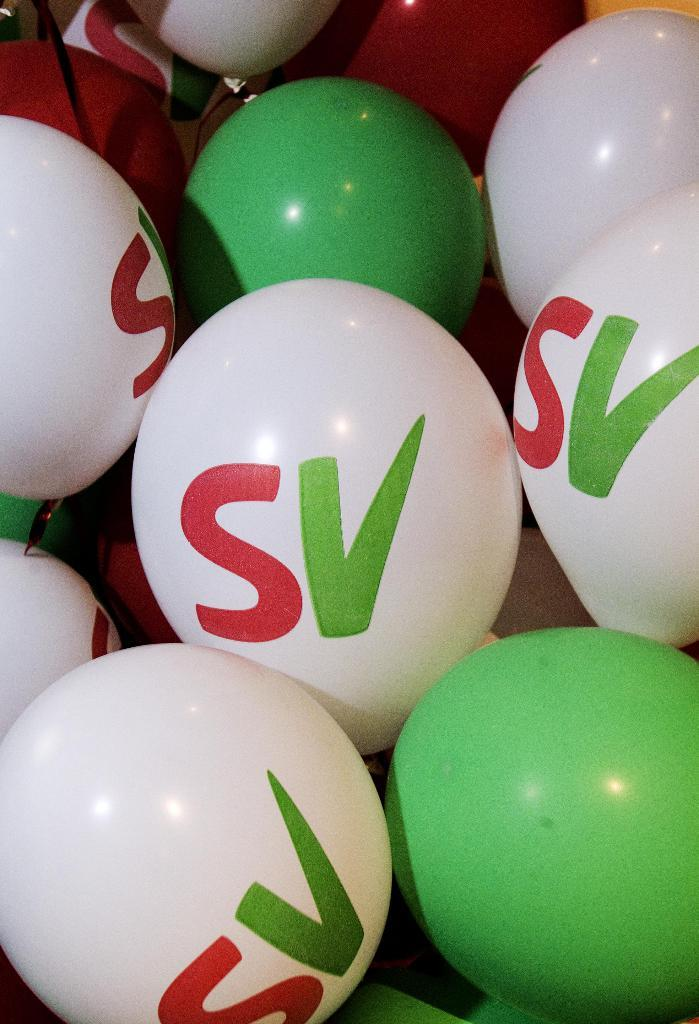What is the main subject of the image? The main subject of the image is many balloons. What colors are the balloons in the image? The balloons are white and green in color. Are there any words or letters on the balloons? Yes, there is text on the balloons. How many family members can be seen holding the tooth-shaped balloons in the image? There are no family members or tooth-shaped balloons present in the image. Can you tell me which vein is responsible for carrying blood to the balloons in the image? There are no veins or blood flow involved with the balloons in the image, as they are inanimate objects. 